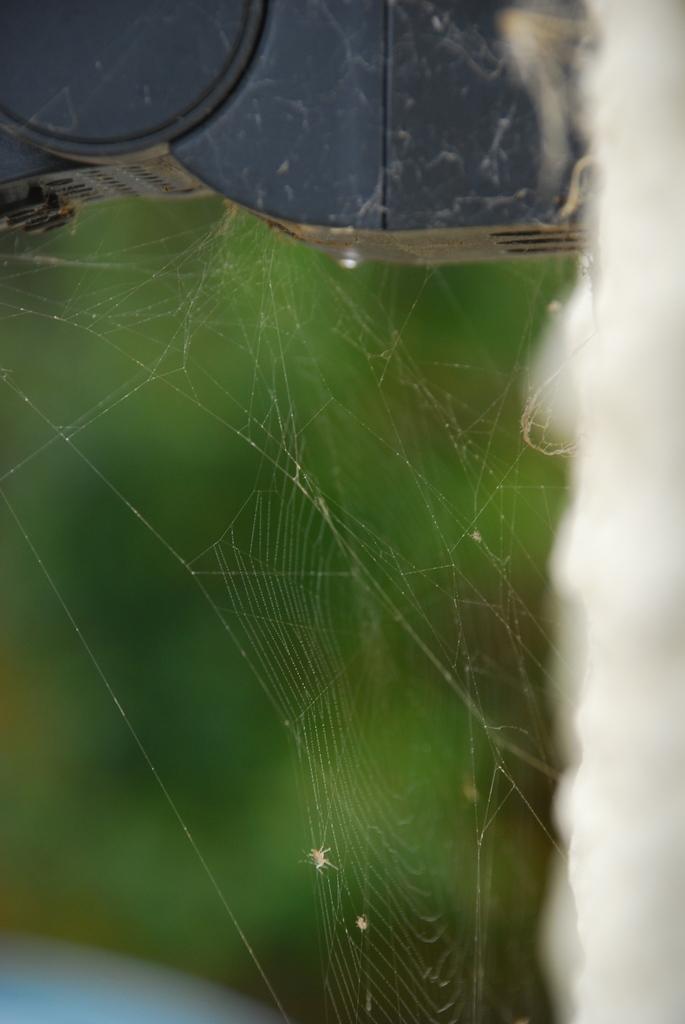How would you summarize this image in a sentence or two? There is a spider web and the background is in green color. 